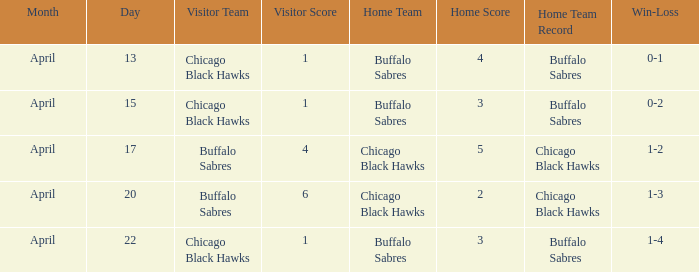Which Date has a Record of 1-4? April 22. 